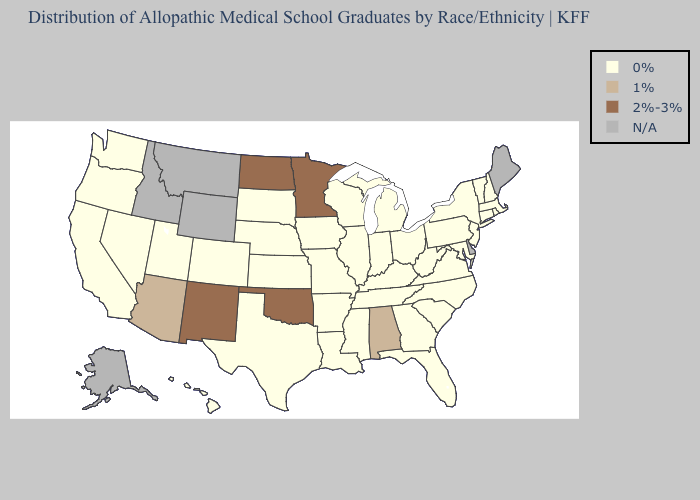Does New Mexico have the highest value in the West?
Be succinct. Yes. What is the highest value in the MidWest ?
Write a very short answer. 2%-3%. Does Oklahoma have the highest value in the South?
Keep it brief. Yes. What is the value of Rhode Island?
Quick response, please. 0%. Which states have the lowest value in the USA?
Concise answer only. Arkansas, California, Colorado, Connecticut, Florida, Georgia, Hawaii, Illinois, Indiana, Iowa, Kansas, Kentucky, Louisiana, Maryland, Massachusetts, Michigan, Mississippi, Missouri, Nebraska, Nevada, New Hampshire, New Jersey, New York, North Carolina, Ohio, Oregon, Pennsylvania, Rhode Island, South Carolina, South Dakota, Tennessee, Texas, Utah, Vermont, Virginia, Washington, West Virginia, Wisconsin. Name the states that have a value in the range 0%?
Answer briefly. Arkansas, California, Colorado, Connecticut, Florida, Georgia, Hawaii, Illinois, Indiana, Iowa, Kansas, Kentucky, Louisiana, Maryland, Massachusetts, Michigan, Mississippi, Missouri, Nebraska, Nevada, New Hampshire, New Jersey, New York, North Carolina, Ohio, Oregon, Pennsylvania, Rhode Island, South Carolina, South Dakota, Tennessee, Texas, Utah, Vermont, Virginia, Washington, West Virginia, Wisconsin. What is the lowest value in the USA?
Keep it brief. 0%. What is the value of North Carolina?
Answer briefly. 0%. Name the states that have a value in the range 0%?
Concise answer only. Arkansas, California, Colorado, Connecticut, Florida, Georgia, Hawaii, Illinois, Indiana, Iowa, Kansas, Kentucky, Louisiana, Maryland, Massachusetts, Michigan, Mississippi, Missouri, Nebraska, Nevada, New Hampshire, New Jersey, New York, North Carolina, Ohio, Oregon, Pennsylvania, Rhode Island, South Carolina, South Dakota, Tennessee, Texas, Utah, Vermont, Virginia, Washington, West Virginia, Wisconsin. What is the value of Montana?
Short answer required. N/A. Name the states that have a value in the range 2%-3%?
Write a very short answer. Minnesota, New Mexico, North Dakota, Oklahoma. Name the states that have a value in the range N/A?
Quick response, please. Alaska, Delaware, Idaho, Maine, Montana, Wyoming. Name the states that have a value in the range 1%?
Short answer required. Alabama, Arizona. 